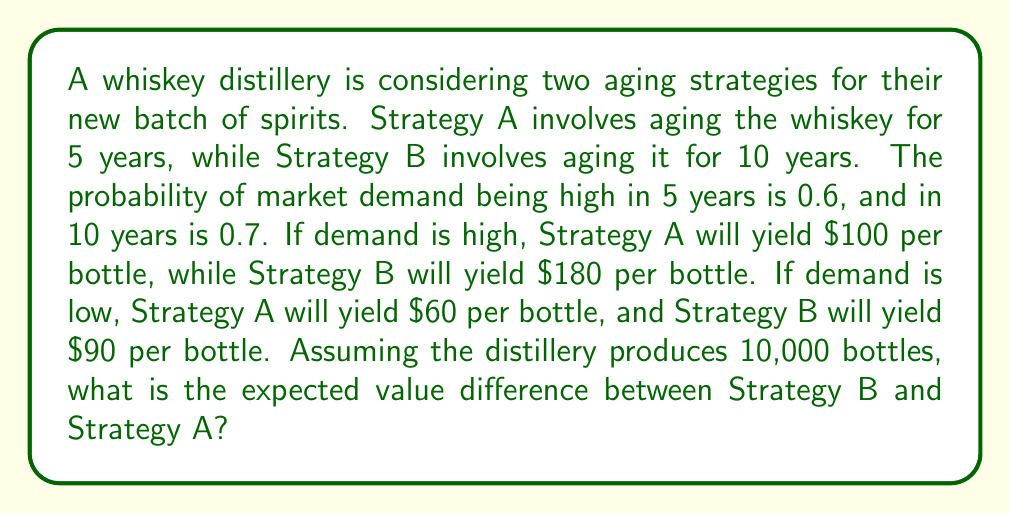Can you solve this math problem? Let's approach this step-by-step:

1. Calculate the expected value for Strategy A:
   - Probability of high demand: 0.6
   - Probability of low demand: 1 - 0.6 = 0.4
   - Expected value per bottle: $$(0.6 \times \$100) + (0.4 \times \$60) = \$60 + \$24 = \$84$$
   - Total expected value: $$\$84 \times 10,000 = \$840,000$$

2. Calculate the expected value for Strategy B:
   - Probability of high demand: 0.7
   - Probability of low demand: 1 - 0.7 = 0.3
   - Expected value per bottle: $$(0.7 \times \$180) + (0.3 \times \$90) = \$126 + \$27 = \$153$$
   - Total expected value: $$\$153 \times 10,000 = \$1,530,000$$

3. Calculate the difference in expected value:
   $$\$1,530,000 - \$840,000 = \$690,000$$

This analysis shows that Strategy B has a higher expected value, which might be due to the higher probability of high demand and the increased value of longer-aged whiskey. However, it's worth noting that this doesn't account for factors like the time value of money or storage costs, which a more comprehensive analysis would include.
Answer: The expected value difference between Strategy B and Strategy A is $690,000. 